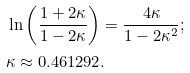Convert formula to latex. <formula><loc_0><loc_0><loc_500><loc_500>& \ln \left ( \frac { 1 + 2 \kappa } { 1 - 2 \kappa } \right ) = \frac { 4 \kappa } { 1 - 2 \kappa ^ { 2 } } ; \\ & \kappa \approx 0 . 4 6 1 2 9 2 .</formula> 